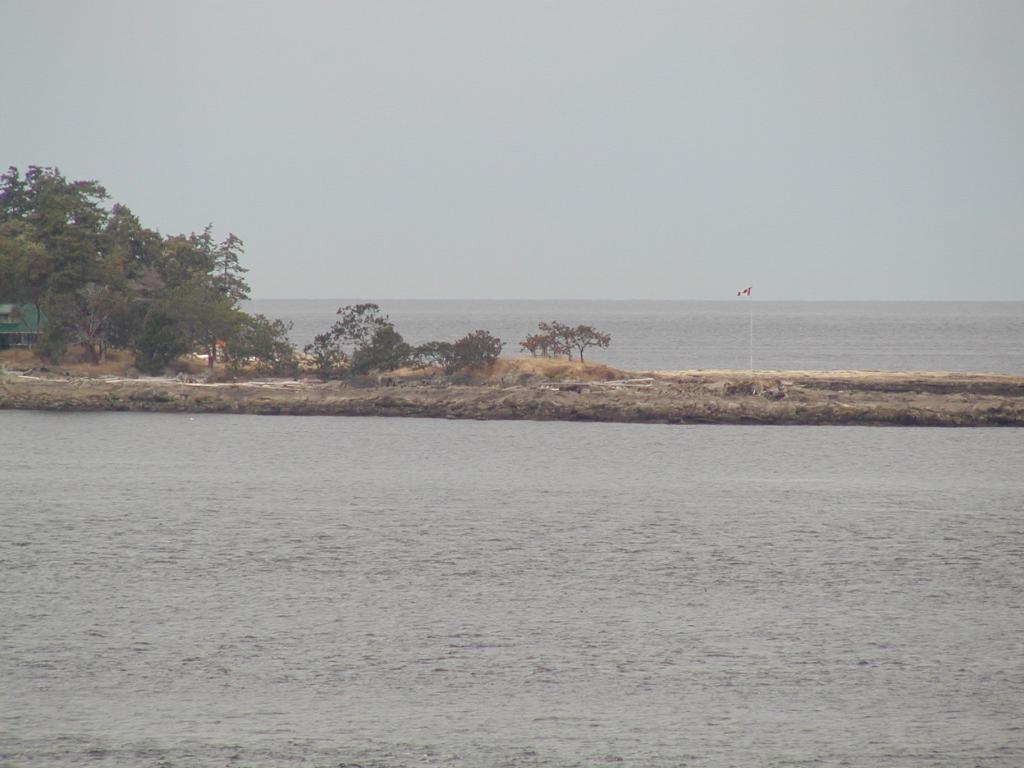What is the primary element in the image? The image consists of water. Can you describe the possible source of the water? The water may be from an ocean. What type of vegetation can be seen in the image? There are trees and plants in the image. What object is on the ground in the image? There is a flag on the ground in the image. Where can the receipt for the boat rental be found in the image? There is no receipt for a boat rental present in the image. What type of berry can be seen growing on the trees in the image? There are no berries visible on the trees in the image. 